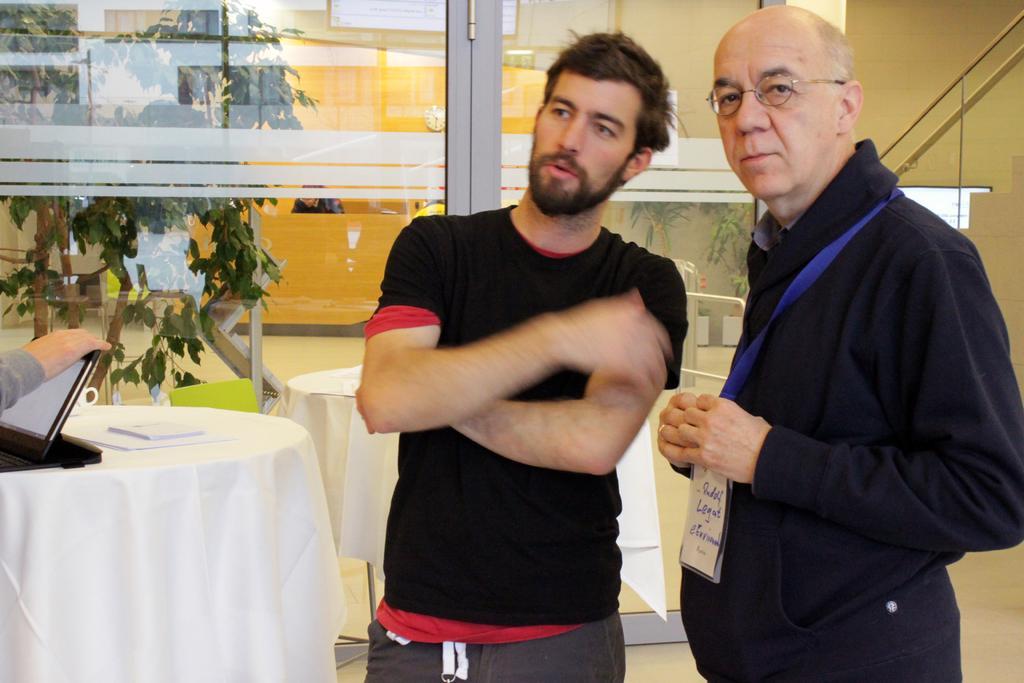In one or two sentences, can you explain what this image depicts? In this image on the right side there is one man who is standing and he is wearing spectacles beside that man there is another man who is standing and he is wearing a black shirt. On the background there is a glass door and on the left side there is one plant and in the middle there are two tables and that tables are covered with a white cloth and on that table there is one laptop and some books are there. 